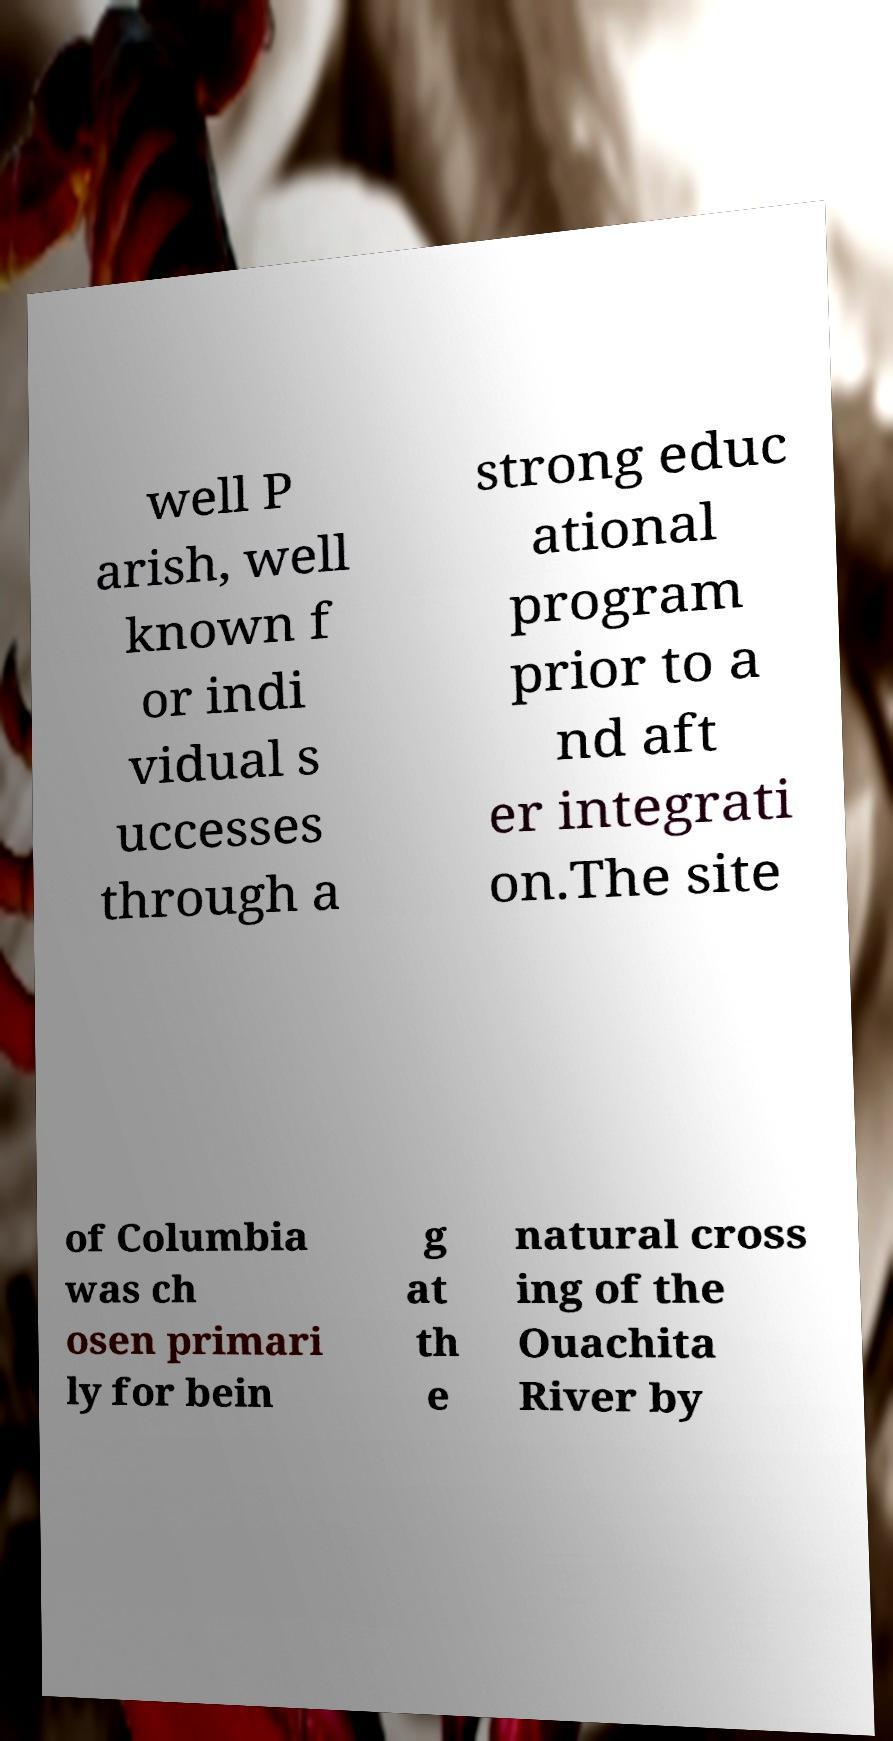Can you accurately transcribe the text from the provided image for me? well P arish, well known f or indi vidual s uccesses through a strong educ ational program prior to a nd aft er integrati on.The site of Columbia was ch osen primari ly for bein g at th e natural cross ing of the Ouachita River by 